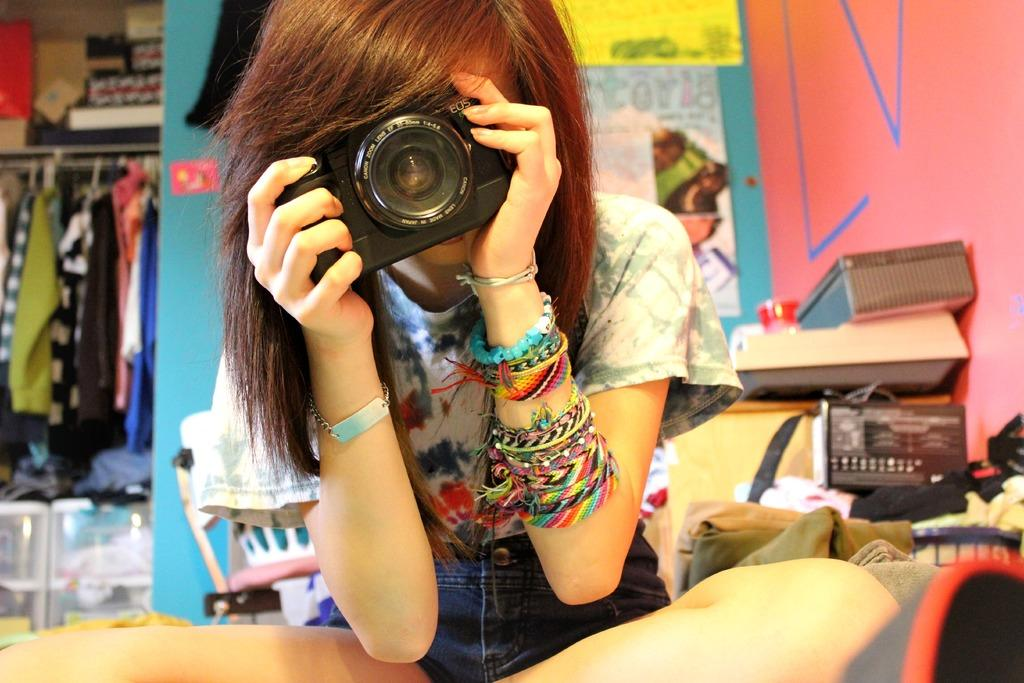What is the girl holding in the image? The girl is holding a camera. Can you describe any accessories the girl is wearing? The girl has bands on her hand. What can be seen on the shelf in the image? There are clothes on a shelf. What is the purpose of the tray in the image? The purpose of the tray is not explicitly stated, but it could be used for holding or organizing items. What is in the basket in the image? There are clothes in a basket. What is on the wall in the image? There are posters on the wall. What type of riddle can be solved by observing the engine in the image? There is no engine present in the image, so it is not possible to solve a riddle based on an engine. 